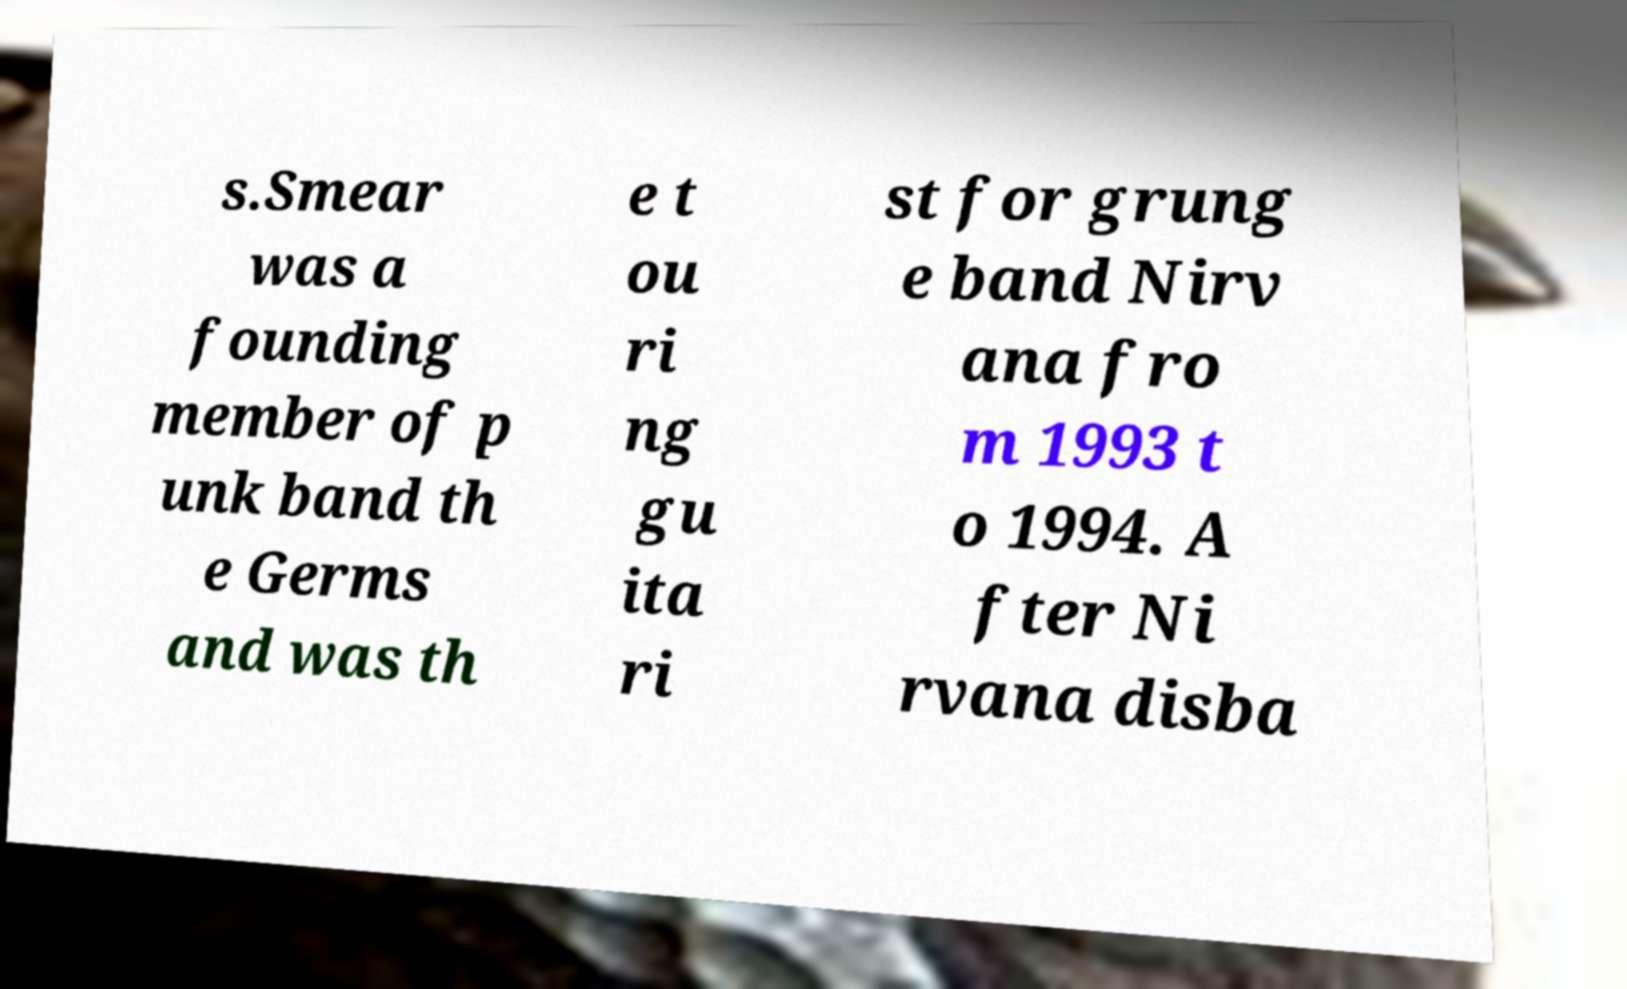Could you extract and type out the text from this image? s.Smear was a founding member of p unk band th e Germs and was th e t ou ri ng gu ita ri st for grung e band Nirv ana fro m 1993 t o 1994. A fter Ni rvana disba 